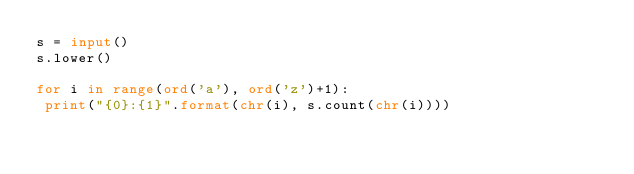Convert code to text. <code><loc_0><loc_0><loc_500><loc_500><_Python_>s = input()
s.lower()

for i in range(ord('a'), ord('z')+1):
 print("{0}:{1}".format(chr(i), s.count(chr(i))))</code> 